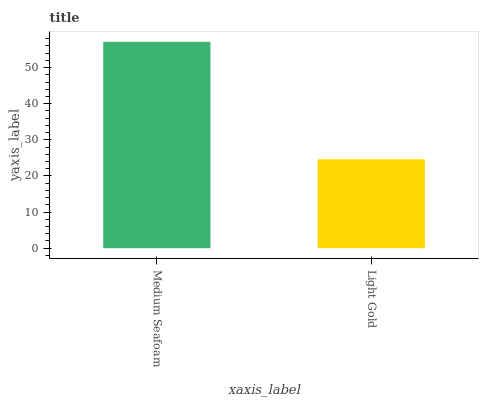Is Light Gold the maximum?
Answer yes or no. No. Is Medium Seafoam greater than Light Gold?
Answer yes or no. Yes. Is Light Gold less than Medium Seafoam?
Answer yes or no. Yes. Is Light Gold greater than Medium Seafoam?
Answer yes or no. No. Is Medium Seafoam less than Light Gold?
Answer yes or no. No. Is Medium Seafoam the high median?
Answer yes or no. Yes. Is Light Gold the low median?
Answer yes or no. Yes. Is Light Gold the high median?
Answer yes or no. No. Is Medium Seafoam the low median?
Answer yes or no. No. 